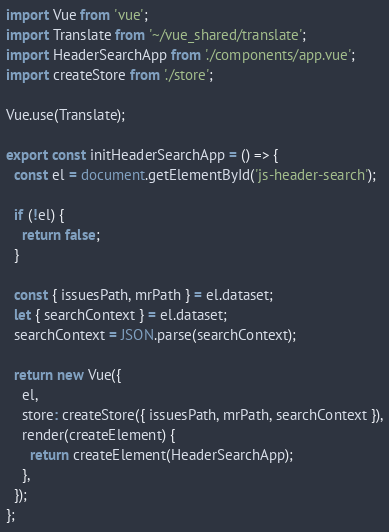Convert code to text. <code><loc_0><loc_0><loc_500><loc_500><_JavaScript_>import Vue from 'vue';
import Translate from '~/vue_shared/translate';
import HeaderSearchApp from './components/app.vue';
import createStore from './store';

Vue.use(Translate);

export const initHeaderSearchApp = () => {
  const el = document.getElementById('js-header-search');

  if (!el) {
    return false;
  }

  const { issuesPath, mrPath } = el.dataset;
  let { searchContext } = el.dataset;
  searchContext = JSON.parse(searchContext);

  return new Vue({
    el,
    store: createStore({ issuesPath, mrPath, searchContext }),
    render(createElement) {
      return createElement(HeaderSearchApp);
    },
  });
};
</code> 